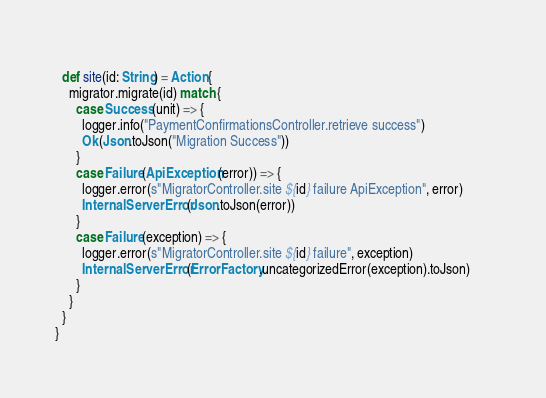<code> <loc_0><loc_0><loc_500><loc_500><_Scala_>  
  def site(id: String) = Action {
    migrator.migrate(id) match {
      case Success(unit) => {
        logger.info("PaymentConfirmationsController.retrieve success")
        Ok(Json.toJson("Migration Success"))
      }      
      case Failure(ApiException(error)) => {
        logger.error(s"MigratorController.site ${id} failure ApiException", error)
        InternalServerError(Json.toJson(error))      
      }
      case Failure(exception) => {
        logger.error(s"MigratorController.site ${id} failure", exception)
        InternalServerError(ErrorFactory.uncategorizedError(exception).toJson)      
      }
    }
  }
}</code> 